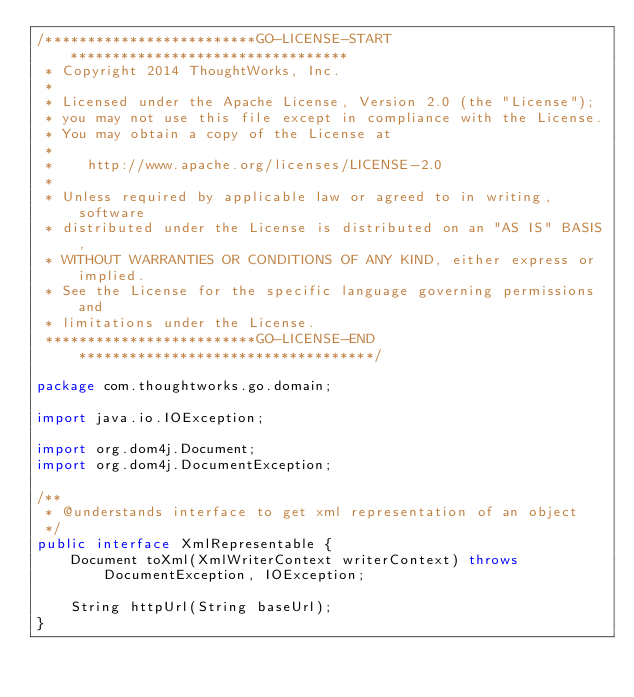<code> <loc_0><loc_0><loc_500><loc_500><_Java_>/*************************GO-LICENSE-START*********************************
 * Copyright 2014 ThoughtWorks, Inc.
 *
 * Licensed under the Apache License, Version 2.0 (the "License");
 * you may not use this file except in compliance with the License.
 * You may obtain a copy of the License at
 *
 *    http://www.apache.org/licenses/LICENSE-2.0
 *
 * Unless required by applicable law or agreed to in writing, software
 * distributed under the License is distributed on an "AS IS" BASIS,
 * WITHOUT WARRANTIES OR CONDITIONS OF ANY KIND, either express or implied.
 * See the License for the specific language governing permissions and
 * limitations under the License.
 *************************GO-LICENSE-END***********************************/

package com.thoughtworks.go.domain;

import java.io.IOException;

import org.dom4j.Document;
import org.dom4j.DocumentException;

/**
 * @understands interface to get xml representation of an object
 */
public interface XmlRepresentable {
    Document toXml(XmlWriterContext writerContext) throws DocumentException, IOException;

    String httpUrl(String baseUrl);
}
</code> 